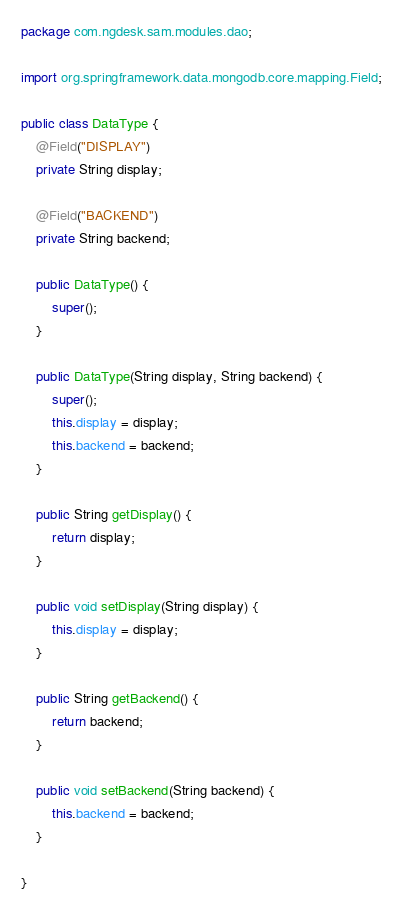<code> <loc_0><loc_0><loc_500><loc_500><_Java_>package com.ngdesk.sam.modules.dao;

import org.springframework.data.mongodb.core.mapping.Field;

public class DataType {
	@Field("DISPLAY")
	private String display;

	@Field("BACKEND")
	private String backend;

	public DataType() {
		super();
	}

	public DataType(String display, String backend) {
		super();
		this.display = display;
		this.backend = backend;
	}

	public String getDisplay() {
		return display;
	}

	public void setDisplay(String display) {
		this.display = display;
	}

	public String getBackend() {
		return backend;
	}

	public void setBackend(String backend) {
		this.backend = backend;
	}

}
</code> 